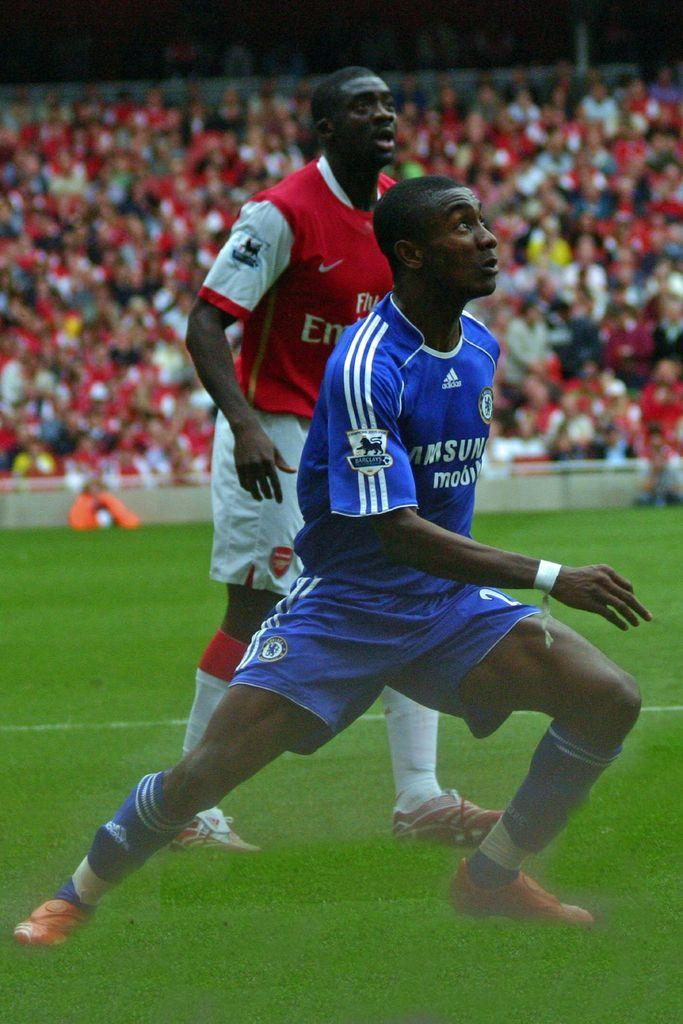How many players are visible on the ground in the image? There are two players on the ground in the image. What is surrounding the ground? There is a fencing around the ground. What can be seen behind the ground? There is a large crowd behind the ground. What type of wine is being served to the players during the game? There is no wine present in the image, and it is not mentioned that the players are being served any beverages. 